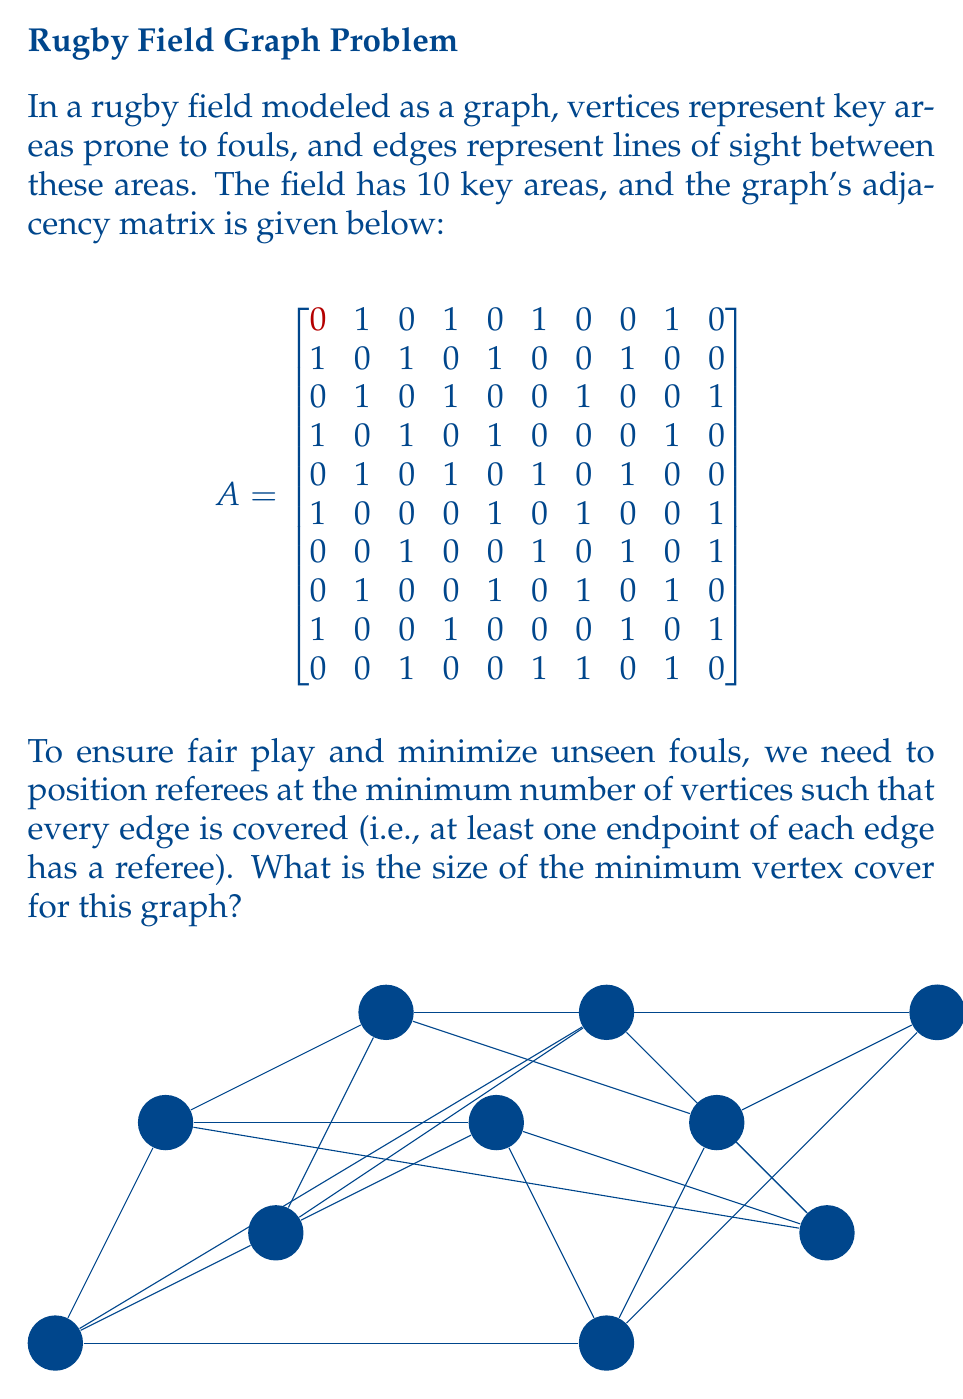Can you answer this question? To find the minimum vertex cover, we'll use the Bron-Kerbosch algorithm to find the maximum independent set, then subtract its size from the total number of vertices.

Step 1: Implement the Bron-Kerbosch algorithm to find all maximal cliques.

Step 2: Identify the largest maximal clique, which is the maximum independent set.

Step 3: The maximum independent set for this graph is {v1, v3, v5, v7, v9}, with size 5.

Step 4: Calculate the minimum vertex cover size:
$$ \text{Minimum Vertex Cover Size} = \text{Total Vertices} - \text{Maximum Independent Set Size} $$
$$ = 10 - 5 = 5 $$

Therefore, we need to position referees at a minimum of 5 vertices to cover all edges and minimize unseen fouls.

This solution ensures that every potential foul area (edge) is monitored by at least one referee, promoting fair play and reducing unsportsmanlike behavior.
Answer: 5 